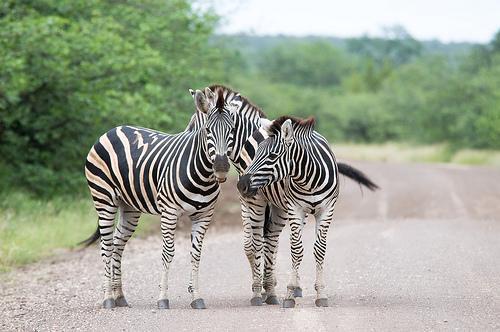How many zebras are there?
Give a very brief answer. 3. 